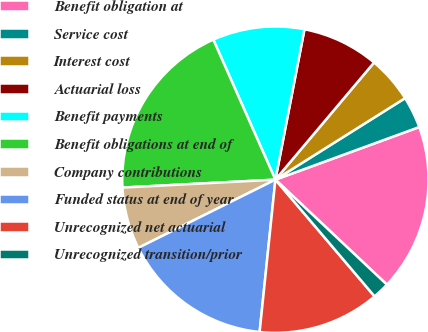Convert chart to OTSL. <chart><loc_0><loc_0><loc_500><loc_500><pie_chart><fcel>Benefit obligation at<fcel>Service cost<fcel>Interest cost<fcel>Actuarial loss<fcel>Benefit payments<fcel>Benefit obligations at end of<fcel>Company contributions<fcel>Funded status at end of year<fcel>Unrecognized net actuarial<fcel>Unrecognized transition/prior<nl><fcel>17.6%<fcel>3.35%<fcel>4.93%<fcel>8.1%<fcel>9.68%<fcel>19.18%<fcel>6.52%<fcel>16.01%<fcel>12.85%<fcel>1.77%<nl></chart> 